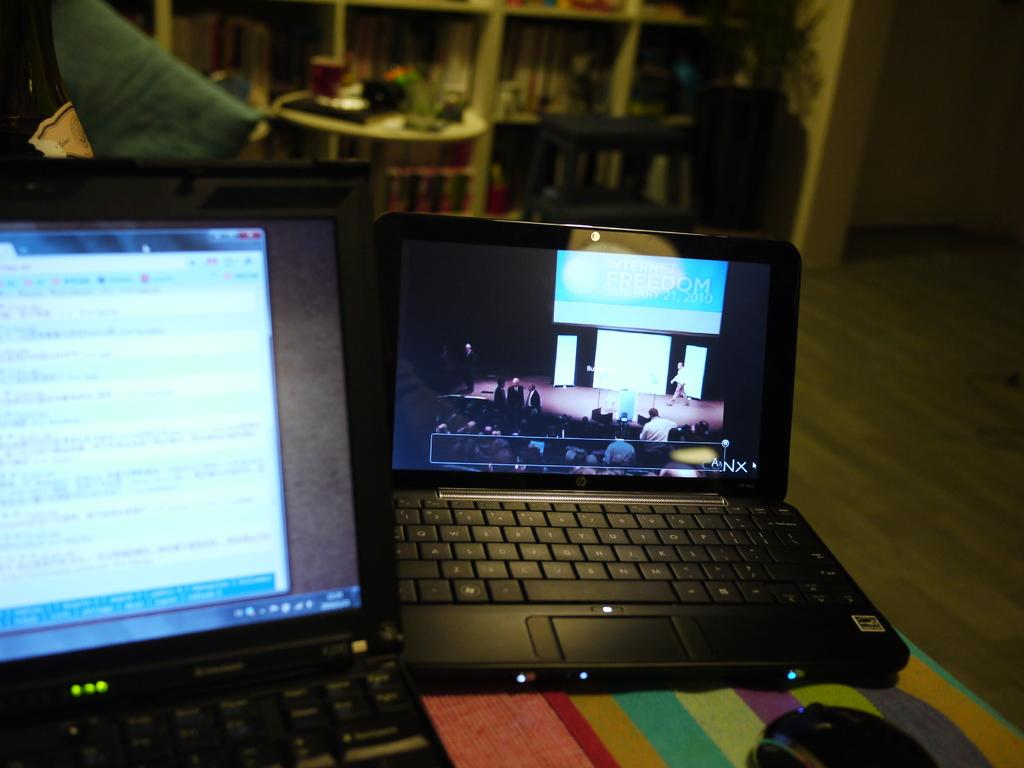<image>
Offer a succinct explanation of the picture presented. two laptops, one of which has internet freedom at the top of the screen 